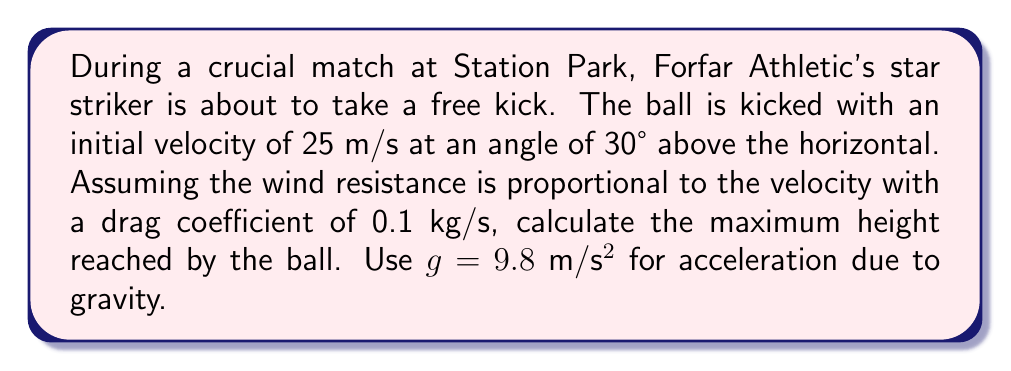Could you help me with this problem? Let's approach this step-by-step:

1) First, we need to set up our equations of motion. With wind resistance, we have:

   $$\frac{d^2x}{dt^2} = -k\frac{dx}{dt}$$
   $$\frac{d^2y}{dt^2} = -g - k\frac{dy}{dt}$$

   Where k is the drag coefficient divided by mass (we'll assume a standard football mass of 0.45 kg).

2) The initial conditions are:
   $$v_0 = 25 \text{ m/s}$$
   $$\theta = 30°$$
   $$v_{0x} = v_0 \cos{\theta} = 25 \cos{30°} = 21.65 \text{ m/s}$$
   $$v_{0y} = v_0 \sin{\theta} = 25 \sin{30°} = 12.5 \text{ m/s}$$

3) The solution for the vertical motion is:

   $$y(t) = -\frac{g}{k^2}\left(kt + \ln{\left(1-e^{-kt}\right)}\right) + \frac{v_{0y}}{k}\left(1-e^{-kt}\right)$$

4) To find the maximum height, we need to find when $\frac{dy}{dt} = 0$:

   $$\frac{dy}{dt} = \frac{g}{k}\left(e^{-kt} - 1\right) + v_{0y}e^{-kt} = 0$$

5) Solving this equation:

   $$t_{max} = \frac{1}{k}\ln{\left(\frac{v_{0y}k}{g} + 1\right)}$$

6) Substituting our values:
   $$k = \frac{0.1}{0.45} = 0.222 \text{ s}^{-1}$$
   $$t_{max} = \frac{1}{0.222}\ln{\left(\frac{12.5 \cdot 0.222}{9.8} + 1\right)} = 1.15 \text{ s}$$

7) Now we can find the maximum height by substituting this time back into our y(t) equation:

   $$y_{max} = -\frac{9.8}{0.222^2}\left(0.222 \cdot 1.15 + \ln{\left(1-e^{-0.222 \cdot 1.15}\right)}\right) + \frac{12.5}{0.222}\left(1-e^{-0.222 \cdot 1.15}\right)$$

8) Calculating this gives us:

   $$y_{max} \approx 7.02 \text{ m}$$
Answer: 7.02 m 